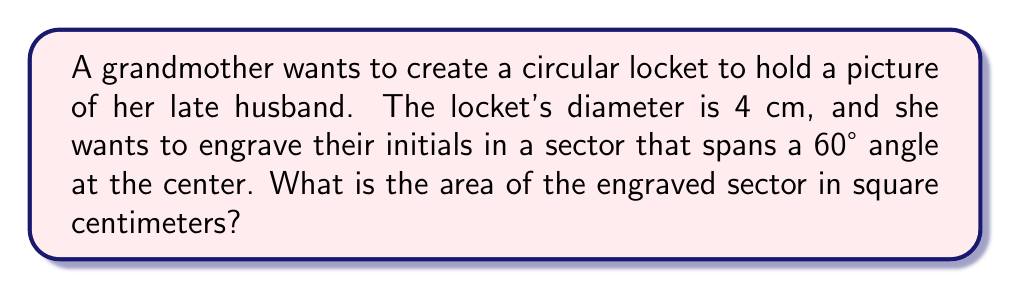Give your solution to this math problem. Let's approach this step-by-step:

1) First, we need to recall the formula for the area of a sector:
   $$A_{sector} = \frac{\theta}{360°} \cdot \pi r^2$$
   Where $\theta$ is the central angle in degrees, and $r$ is the radius.

2) We're given the diameter of 4 cm, so the radius is:
   $$r = \frac{4}{2} = 2 \text{ cm}$$

3) We're also given the central angle of 60°.

4) Now, let's substitute these values into our formula:
   $$A_{sector} = \frac{60°}{360°} \cdot \pi (2\text{ cm})^2$$

5) Simplify:
   $$A_{sector} = \frac{1}{6} \cdot \pi \cdot 4\text{ cm}^2$$
   $$A_{sector} = \frac{2}{3} \pi \text{ cm}^2$$

6) If we want to calculate the exact value:
   $$A_{sector} \approx 2.0944\text{ cm}^2$$

[asy]
unitsize(1cm);
draw(circle((0,0),2));
draw((0,0)--(2,0));
draw((0,0)--(1,1.732));
label("60°", (0.5,0.3));
label("2 cm", (1,-0.3));
fill(arc((0,0),2,0,60)--cycle,gray(0.7));
[/asy]
Answer: $\frac{2}{3}\pi \text{ cm}^2$ or approximately $2.0944\text{ cm}^2$ 